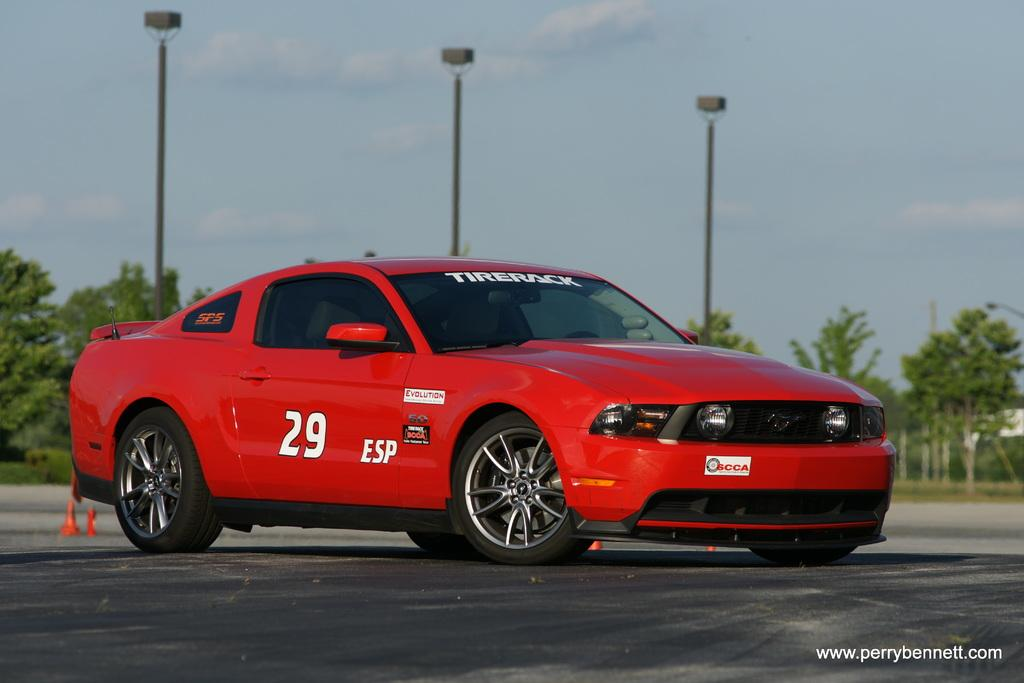What is the color of the vehicle in the image? The vehicle in the image is red. What feature does the vehicle have that allows it to move? The vehicle has wheels. Where is the vehicle located in the image? The vehicle is on the ground. What can be seen in the background of the image? There are trees and poles in the background of the image. What type of story is being told by the vehicle in the image? There is no story being told by the vehicle in the image; it is simply a stationary object. 